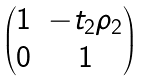Convert formula to latex. <formula><loc_0><loc_0><loc_500><loc_500>\begin{pmatrix} 1 & - t _ { 2 } \rho _ { 2 } \\ 0 & 1 \end{pmatrix}</formula> 